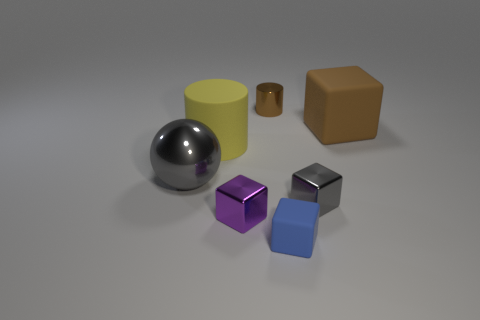What number of other small gray metallic objects have the same shape as the tiny gray shiny thing?
Provide a short and direct response. 0. What is the material of the large thing that is the same color as the tiny metallic cylinder?
Provide a short and direct response. Rubber. Is the gray ball made of the same material as the big brown thing?
Provide a short and direct response. No. What number of tiny shiny cubes are on the left side of the metallic cube that is right of the matte block on the left side of the gray cube?
Ensure brevity in your answer.  1. Are there any red cylinders that have the same material as the tiny gray block?
Keep it short and to the point. No. What is the size of the cube that is the same color as the shiny sphere?
Provide a succinct answer. Small. Is the number of tiny green matte blocks less than the number of tiny blue things?
Keep it short and to the point. Yes. There is a shiny cube that is to the right of the tiny brown cylinder; does it have the same color as the rubber cylinder?
Give a very brief answer. No. There is a gray thing that is in front of the gray thing that is to the left of the cylinder in front of the large brown rubber cube; what is its material?
Provide a short and direct response. Metal. Are there any big objects of the same color as the small cylinder?
Your response must be concise. Yes. 